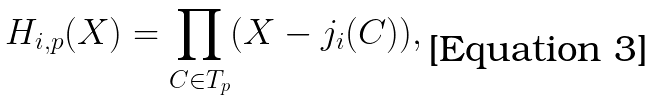<formula> <loc_0><loc_0><loc_500><loc_500>H _ { i , p } ( X ) = \prod _ { C \in T _ { p } } ( X - j _ { i } ( C ) ) ,</formula> 